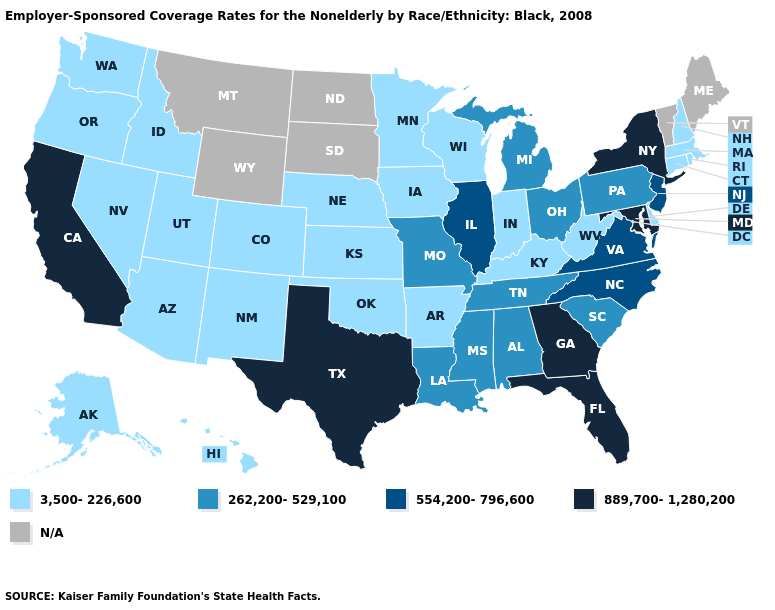Name the states that have a value in the range 3,500-226,600?
Quick response, please. Alaska, Arizona, Arkansas, Colorado, Connecticut, Delaware, Hawaii, Idaho, Indiana, Iowa, Kansas, Kentucky, Massachusetts, Minnesota, Nebraska, Nevada, New Hampshire, New Mexico, Oklahoma, Oregon, Rhode Island, Utah, Washington, West Virginia, Wisconsin. Does Rhode Island have the highest value in the Northeast?
Concise answer only. No. What is the value of Texas?
Concise answer only. 889,700-1,280,200. What is the highest value in the USA?
Give a very brief answer. 889,700-1,280,200. Name the states that have a value in the range 554,200-796,600?
Be succinct. Illinois, New Jersey, North Carolina, Virginia. Does Florida have the highest value in the USA?
Write a very short answer. Yes. Does the map have missing data?
Quick response, please. Yes. What is the value of Tennessee?
Be succinct. 262,200-529,100. What is the highest value in states that border Kansas?
Concise answer only. 262,200-529,100. What is the value of West Virginia?
Concise answer only. 3,500-226,600. How many symbols are there in the legend?
Quick response, please. 5. What is the value of Michigan?
Give a very brief answer. 262,200-529,100. Which states hav the highest value in the MidWest?
Quick response, please. Illinois. Does West Virginia have the lowest value in the USA?
Quick response, please. Yes. 